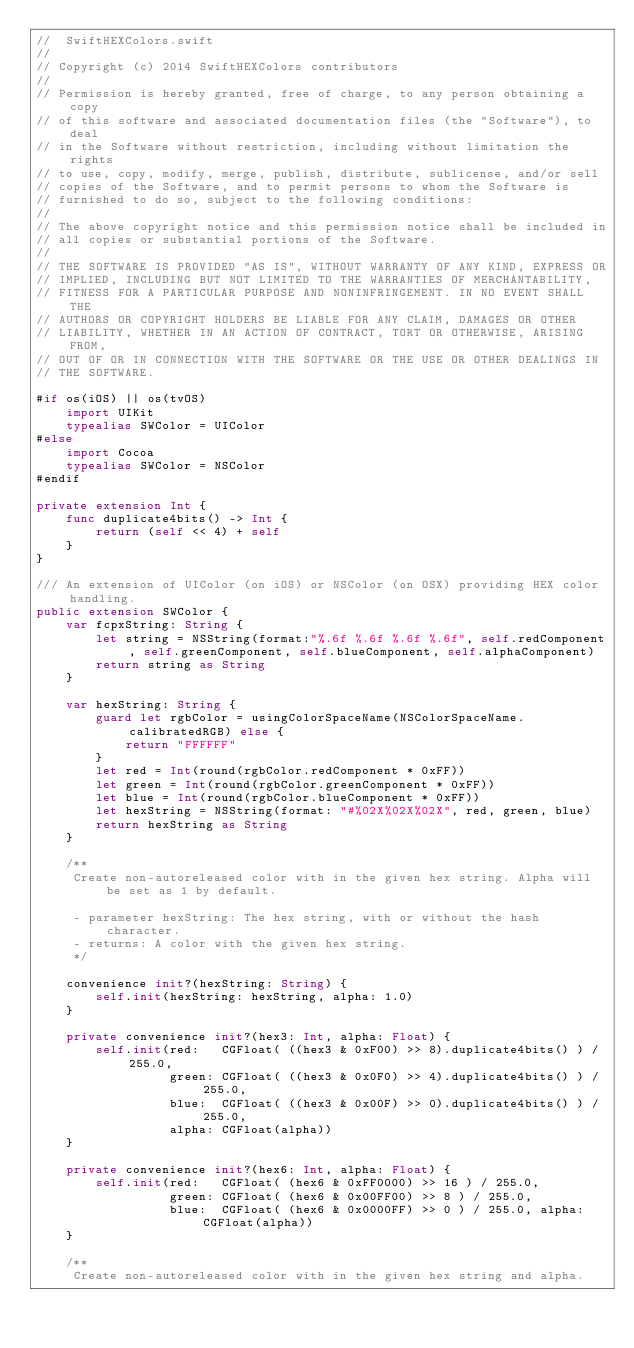<code> <loc_0><loc_0><loc_500><loc_500><_Swift_>//  SwiftHEXColors.swift
//
// Copyright (c) 2014 SwiftHEXColors contributors
//
// Permission is hereby granted, free of charge, to any person obtaining a copy
// of this software and associated documentation files (the "Software"), to deal
// in the Software without restriction, including without limitation the rights
// to use, copy, modify, merge, publish, distribute, sublicense, and/or sell
// copies of the Software, and to permit persons to whom the Software is
// furnished to do so, subject to the following conditions:
//
// The above copyright notice and this permission notice shall be included in
// all copies or substantial portions of the Software.
//
// THE SOFTWARE IS PROVIDED "AS IS", WITHOUT WARRANTY OF ANY KIND, EXPRESS OR
// IMPLIED, INCLUDING BUT NOT LIMITED TO THE WARRANTIES OF MERCHANTABILITY,
// FITNESS FOR A PARTICULAR PURPOSE AND NONINFRINGEMENT. IN NO EVENT SHALL THE
// AUTHORS OR COPYRIGHT HOLDERS BE LIABLE FOR ANY CLAIM, DAMAGES OR OTHER
// LIABILITY, WHETHER IN AN ACTION OF CONTRACT, TORT OR OTHERWISE, ARISING FROM,
// OUT OF OR IN CONNECTION WITH THE SOFTWARE OR THE USE OR OTHER DEALINGS IN
// THE SOFTWARE.

#if os(iOS) || os(tvOS)
    import UIKit
    typealias SWColor = UIColor
#else
    import Cocoa
    typealias SWColor = NSColor
#endif

private extension Int {
    func duplicate4bits() -> Int {
        return (self << 4) + self
    }
}

/// An extension of UIColor (on iOS) or NSColor (on OSX) providing HEX color handling.
public extension SWColor {
    var fcpxString: String {
        let string = NSString(format:"%.6f %.6f %.6f %.6f", self.redComponent, self.greenComponent, self.blueComponent, self.alphaComponent)
        return string as String
    }

    var hexString: String {
        guard let rgbColor = usingColorSpaceName(NSColorSpaceName.calibratedRGB) else {
            return "FFFFFF"
        }
        let red = Int(round(rgbColor.redComponent * 0xFF))
        let green = Int(round(rgbColor.greenComponent * 0xFF))
        let blue = Int(round(rgbColor.blueComponent * 0xFF))
        let hexString = NSString(format: "#%02X%02X%02X", red, green, blue)
        return hexString as String
    }

    /**
     Create non-autoreleased color with in the given hex string. Alpha will be set as 1 by default.

     - parameter hexString: The hex string, with or without the hash character.
     - returns: A color with the given hex string.
     */
    
    convenience init?(hexString: String) {
        self.init(hexString: hexString, alpha: 1.0)
    }

    private convenience init?(hex3: Int, alpha: Float) {
        self.init(red:   CGFloat( ((hex3 & 0xF00) >> 8).duplicate4bits() ) / 255.0,
                  green: CGFloat( ((hex3 & 0x0F0) >> 4).duplicate4bits() ) / 255.0,
                  blue:  CGFloat( ((hex3 & 0x00F) >> 0).duplicate4bits() ) / 255.0,
                  alpha: CGFloat(alpha))
    }

    private convenience init?(hex6: Int, alpha: Float) {
        self.init(red:   CGFloat( (hex6 & 0xFF0000) >> 16 ) / 255.0,
                  green: CGFloat( (hex6 & 0x00FF00) >> 8 ) / 255.0,
                  blue:  CGFloat( (hex6 & 0x0000FF) >> 0 ) / 255.0, alpha: CGFloat(alpha))
    }

    /**
     Create non-autoreleased color with in the given hex string and alpha.
</code> 